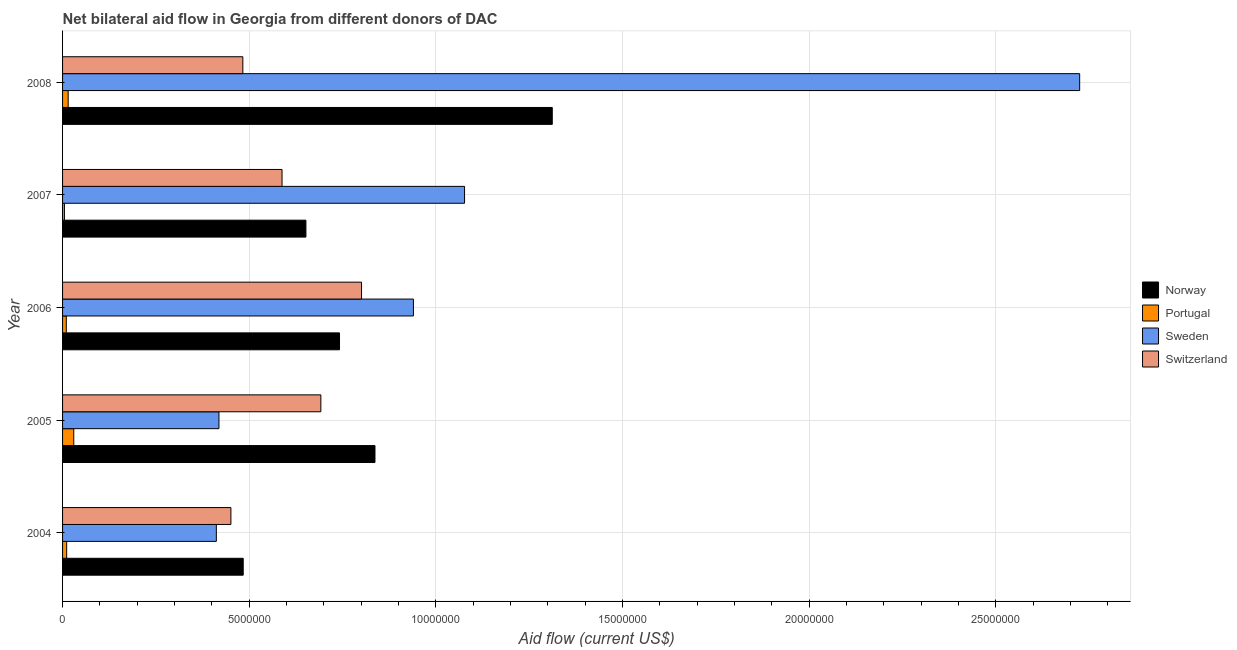Are the number of bars per tick equal to the number of legend labels?
Your answer should be compact. Yes. Are the number of bars on each tick of the Y-axis equal?
Provide a succinct answer. Yes. How many bars are there on the 3rd tick from the top?
Offer a terse response. 4. What is the amount of aid given by portugal in 2008?
Provide a short and direct response. 1.50e+05. Across all years, what is the maximum amount of aid given by sweden?
Make the answer very short. 2.72e+07. Across all years, what is the minimum amount of aid given by switzerland?
Provide a succinct answer. 4.51e+06. In which year was the amount of aid given by sweden maximum?
Keep it short and to the point. 2008. What is the total amount of aid given by switzerland in the graph?
Your answer should be compact. 3.02e+07. What is the difference between the amount of aid given by portugal in 2005 and that in 2006?
Offer a terse response. 2.00e+05. What is the difference between the amount of aid given by norway in 2004 and the amount of aid given by sweden in 2006?
Offer a terse response. -4.56e+06. What is the average amount of aid given by sweden per year?
Your answer should be compact. 1.11e+07. In the year 2005, what is the difference between the amount of aid given by switzerland and amount of aid given by norway?
Your answer should be compact. -1.45e+06. What is the ratio of the amount of aid given by portugal in 2004 to that in 2005?
Offer a terse response. 0.37. Is the amount of aid given by sweden in 2007 less than that in 2008?
Keep it short and to the point. Yes. Is the difference between the amount of aid given by norway in 2005 and 2008 greater than the difference between the amount of aid given by switzerland in 2005 and 2008?
Keep it short and to the point. No. What is the difference between the highest and the second highest amount of aid given by sweden?
Offer a very short reply. 1.65e+07. What is the difference between the highest and the lowest amount of aid given by sweden?
Offer a terse response. 2.31e+07. What does the 2nd bar from the top in 2004 represents?
Make the answer very short. Sweden. What does the 4th bar from the bottom in 2008 represents?
Make the answer very short. Switzerland. Are all the bars in the graph horizontal?
Keep it short and to the point. Yes. Are the values on the major ticks of X-axis written in scientific E-notation?
Your answer should be very brief. No. How many legend labels are there?
Your answer should be very brief. 4. How are the legend labels stacked?
Make the answer very short. Vertical. What is the title of the graph?
Provide a succinct answer. Net bilateral aid flow in Georgia from different donors of DAC. What is the label or title of the X-axis?
Provide a short and direct response. Aid flow (current US$). What is the Aid flow (current US$) in Norway in 2004?
Your answer should be very brief. 4.84e+06. What is the Aid flow (current US$) of Portugal in 2004?
Ensure brevity in your answer.  1.10e+05. What is the Aid flow (current US$) of Sweden in 2004?
Offer a terse response. 4.12e+06. What is the Aid flow (current US$) of Switzerland in 2004?
Your response must be concise. 4.51e+06. What is the Aid flow (current US$) of Norway in 2005?
Make the answer very short. 8.37e+06. What is the Aid flow (current US$) in Portugal in 2005?
Your answer should be very brief. 3.00e+05. What is the Aid flow (current US$) of Sweden in 2005?
Make the answer very short. 4.19e+06. What is the Aid flow (current US$) of Switzerland in 2005?
Provide a short and direct response. 6.92e+06. What is the Aid flow (current US$) in Norway in 2006?
Offer a terse response. 7.42e+06. What is the Aid flow (current US$) of Sweden in 2006?
Give a very brief answer. 9.40e+06. What is the Aid flow (current US$) of Switzerland in 2006?
Offer a terse response. 8.01e+06. What is the Aid flow (current US$) in Norway in 2007?
Keep it short and to the point. 6.52e+06. What is the Aid flow (current US$) of Sweden in 2007?
Your answer should be very brief. 1.08e+07. What is the Aid flow (current US$) of Switzerland in 2007?
Keep it short and to the point. 5.88e+06. What is the Aid flow (current US$) in Norway in 2008?
Your answer should be compact. 1.31e+07. What is the Aid flow (current US$) of Portugal in 2008?
Your answer should be compact. 1.50e+05. What is the Aid flow (current US$) in Sweden in 2008?
Keep it short and to the point. 2.72e+07. What is the Aid flow (current US$) in Switzerland in 2008?
Your response must be concise. 4.83e+06. Across all years, what is the maximum Aid flow (current US$) in Norway?
Make the answer very short. 1.31e+07. Across all years, what is the maximum Aid flow (current US$) in Portugal?
Offer a terse response. 3.00e+05. Across all years, what is the maximum Aid flow (current US$) of Sweden?
Make the answer very short. 2.72e+07. Across all years, what is the maximum Aid flow (current US$) in Switzerland?
Give a very brief answer. 8.01e+06. Across all years, what is the minimum Aid flow (current US$) in Norway?
Ensure brevity in your answer.  4.84e+06. Across all years, what is the minimum Aid flow (current US$) in Portugal?
Your response must be concise. 5.00e+04. Across all years, what is the minimum Aid flow (current US$) of Sweden?
Your answer should be very brief. 4.12e+06. Across all years, what is the minimum Aid flow (current US$) of Switzerland?
Provide a short and direct response. 4.51e+06. What is the total Aid flow (current US$) in Norway in the graph?
Give a very brief answer. 4.03e+07. What is the total Aid flow (current US$) in Portugal in the graph?
Your answer should be compact. 7.10e+05. What is the total Aid flow (current US$) in Sweden in the graph?
Offer a very short reply. 5.57e+07. What is the total Aid flow (current US$) of Switzerland in the graph?
Offer a very short reply. 3.02e+07. What is the difference between the Aid flow (current US$) of Norway in 2004 and that in 2005?
Give a very brief answer. -3.53e+06. What is the difference between the Aid flow (current US$) in Sweden in 2004 and that in 2005?
Make the answer very short. -7.00e+04. What is the difference between the Aid flow (current US$) in Switzerland in 2004 and that in 2005?
Offer a terse response. -2.41e+06. What is the difference between the Aid flow (current US$) of Norway in 2004 and that in 2006?
Provide a short and direct response. -2.58e+06. What is the difference between the Aid flow (current US$) of Portugal in 2004 and that in 2006?
Your response must be concise. 10000. What is the difference between the Aid flow (current US$) in Sweden in 2004 and that in 2006?
Give a very brief answer. -5.28e+06. What is the difference between the Aid flow (current US$) in Switzerland in 2004 and that in 2006?
Make the answer very short. -3.50e+06. What is the difference between the Aid flow (current US$) in Norway in 2004 and that in 2007?
Offer a terse response. -1.68e+06. What is the difference between the Aid flow (current US$) of Sweden in 2004 and that in 2007?
Your answer should be compact. -6.65e+06. What is the difference between the Aid flow (current US$) of Switzerland in 2004 and that in 2007?
Provide a succinct answer. -1.37e+06. What is the difference between the Aid flow (current US$) in Norway in 2004 and that in 2008?
Keep it short and to the point. -8.28e+06. What is the difference between the Aid flow (current US$) of Portugal in 2004 and that in 2008?
Keep it short and to the point. -4.00e+04. What is the difference between the Aid flow (current US$) of Sweden in 2004 and that in 2008?
Provide a succinct answer. -2.31e+07. What is the difference between the Aid flow (current US$) in Switzerland in 2004 and that in 2008?
Keep it short and to the point. -3.20e+05. What is the difference between the Aid flow (current US$) of Norway in 2005 and that in 2006?
Your answer should be compact. 9.50e+05. What is the difference between the Aid flow (current US$) in Sweden in 2005 and that in 2006?
Provide a succinct answer. -5.21e+06. What is the difference between the Aid flow (current US$) of Switzerland in 2005 and that in 2006?
Give a very brief answer. -1.09e+06. What is the difference between the Aid flow (current US$) of Norway in 2005 and that in 2007?
Offer a very short reply. 1.85e+06. What is the difference between the Aid flow (current US$) in Sweden in 2005 and that in 2007?
Your response must be concise. -6.58e+06. What is the difference between the Aid flow (current US$) of Switzerland in 2005 and that in 2007?
Ensure brevity in your answer.  1.04e+06. What is the difference between the Aid flow (current US$) of Norway in 2005 and that in 2008?
Offer a very short reply. -4.75e+06. What is the difference between the Aid flow (current US$) in Portugal in 2005 and that in 2008?
Make the answer very short. 1.50e+05. What is the difference between the Aid flow (current US$) in Sweden in 2005 and that in 2008?
Make the answer very short. -2.31e+07. What is the difference between the Aid flow (current US$) in Switzerland in 2005 and that in 2008?
Make the answer very short. 2.09e+06. What is the difference between the Aid flow (current US$) of Sweden in 2006 and that in 2007?
Ensure brevity in your answer.  -1.37e+06. What is the difference between the Aid flow (current US$) in Switzerland in 2006 and that in 2007?
Give a very brief answer. 2.13e+06. What is the difference between the Aid flow (current US$) of Norway in 2006 and that in 2008?
Make the answer very short. -5.70e+06. What is the difference between the Aid flow (current US$) of Portugal in 2006 and that in 2008?
Give a very brief answer. -5.00e+04. What is the difference between the Aid flow (current US$) in Sweden in 2006 and that in 2008?
Ensure brevity in your answer.  -1.78e+07. What is the difference between the Aid flow (current US$) in Switzerland in 2006 and that in 2008?
Keep it short and to the point. 3.18e+06. What is the difference between the Aid flow (current US$) in Norway in 2007 and that in 2008?
Give a very brief answer. -6.60e+06. What is the difference between the Aid flow (current US$) in Sweden in 2007 and that in 2008?
Keep it short and to the point. -1.65e+07. What is the difference between the Aid flow (current US$) of Switzerland in 2007 and that in 2008?
Keep it short and to the point. 1.05e+06. What is the difference between the Aid flow (current US$) of Norway in 2004 and the Aid flow (current US$) of Portugal in 2005?
Your answer should be very brief. 4.54e+06. What is the difference between the Aid flow (current US$) of Norway in 2004 and the Aid flow (current US$) of Sweden in 2005?
Give a very brief answer. 6.50e+05. What is the difference between the Aid flow (current US$) in Norway in 2004 and the Aid flow (current US$) in Switzerland in 2005?
Your answer should be very brief. -2.08e+06. What is the difference between the Aid flow (current US$) in Portugal in 2004 and the Aid flow (current US$) in Sweden in 2005?
Your answer should be very brief. -4.08e+06. What is the difference between the Aid flow (current US$) in Portugal in 2004 and the Aid flow (current US$) in Switzerland in 2005?
Ensure brevity in your answer.  -6.81e+06. What is the difference between the Aid flow (current US$) of Sweden in 2004 and the Aid flow (current US$) of Switzerland in 2005?
Ensure brevity in your answer.  -2.80e+06. What is the difference between the Aid flow (current US$) of Norway in 2004 and the Aid flow (current US$) of Portugal in 2006?
Ensure brevity in your answer.  4.74e+06. What is the difference between the Aid flow (current US$) in Norway in 2004 and the Aid flow (current US$) in Sweden in 2006?
Provide a succinct answer. -4.56e+06. What is the difference between the Aid flow (current US$) of Norway in 2004 and the Aid flow (current US$) of Switzerland in 2006?
Offer a terse response. -3.17e+06. What is the difference between the Aid flow (current US$) of Portugal in 2004 and the Aid flow (current US$) of Sweden in 2006?
Offer a terse response. -9.29e+06. What is the difference between the Aid flow (current US$) in Portugal in 2004 and the Aid flow (current US$) in Switzerland in 2006?
Ensure brevity in your answer.  -7.90e+06. What is the difference between the Aid flow (current US$) of Sweden in 2004 and the Aid flow (current US$) of Switzerland in 2006?
Your response must be concise. -3.89e+06. What is the difference between the Aid flow (current US$) in Norway in 2004 and the Aid flow (current US$) in Portugal in 2007?
Your answer should be compact. 4.79e+06. What is the difference between the Aid flow (current US$) of Norway in 2004 and the Aid flow (current US$) of Sweden in 2007?
Give a very brief answer. -5.93e+06. What is the difference between the Aid flow (current US$) in Norway in 2004 and the Aid flow (current US$) in Switzerland in 2007?
Your answer should be compact. -1.04e+06. What is the difference between the Aid flow (current US$) in Portugal in 2004 and the Aid flow (current US$) in Sweden in 2007?
Keep it short and to the point. -1.07e+07. What is the difference between the Aid flow (current US$) in Portugal in 2004 and the Aid flow (current US$) in Switzerland in 2007?
Give a very brief answer. -5.77e+06. What is the difference between the Aid flow (current US$) of Sweden in 2004 and the Aid flow (current US$) of Switzerland in 2007?
Provide a short and direct response. -1.76e+06. What is the difference between the Aid flow (current US$) of Norway in 2004 and the Aid flow (current US$) of Portugal in 2008?
Your answer should be very brief. 4.69e+06. What is the difference between the Aid flow (current US$) in Norway in 2004 and the Aid flow (current US$) in Sweden in 2008?
Keep it short and to the point. -2.24e+07. What is the difference between the Aid flow (current US$) in Norway in 2004 and the Aid flow (current US$) in Switzerland in 2008?
Your response must be concise. 10000. What is the difference between the Aid flow (current US$) in Portugal in 2004 and the Aid flow (current US$) in Sweden in 2008?
Your answer should be very brief. -2.71e+07. What is the difference between the Aid flow (current US$) in Portugal in 2004 and the Aid flow (current US$) in Switzerland in 2008?
Your response must be concise. -4.72e+06. What is the difference between the Aid flow (current US$) in Sweden in 2004 and the Aid flow (current US$) in Switzerland in 2008?
Provide a short and direct response. -7.10e+05. What is the difference between the Aid flow (current US$) in Norway in 2005 and the Aid flow (current US$) in Portugal in 2006?
Make the answer very short. 8.27e+06. What is the difference between the Aid flow (current US$) of Norway in 2005 and the Aid flow (current US$) of Sweden in 2006?
Keep it short and to the point. -1.03e+06. What is the difference between the Aid flow (current US$) in Norway in 2005 and the Aid flow (current US$) in Switzerland in 2006?
Give a very brief answer. 3.60e+05. What is the difference between the Aid flow (current US$) in Portugal in 2005 and the Aid flow (current US$) in Sweden in 2006?
Your response must be concise. -9.10e+06. What is the difference between the Aid flow (current US$) of Portugal in 2005 and the Aid flow (current US$) of Switzerland in 2006?
Offer a terse response. -7.71e+06. What is the difference between the Aid flow (current US$) in Sweden in 2005 and the Aid flow (current US$) in Switzerland in 2006?
Make the answer very short. -3.82e+06. What is the difference between the Aid flow (current US$) of Norway in 2005 and the Aid flow (current US$) of Portugal in 2007?
Offer a very short reply. 8.32e+06. What is the difference between the Aid flow (current US$) of Norway in 2005 and the Aid flow (current US$) of Sweden in 2007?
Your answer should be very brief. -2.40e+06. What is the difference between the Aid flow (current US$) of Norway in 2005 and the Aid flow (current US$) of Switzerland in 2007?
Give a very brief answer. 2.49e+06. What is the difference between the Aid flow (current US$) in Portugal in 2005 and the Aid flow (current US$) in Sweden in 2007?
Ensure brevity in your answer.  -1.05e+07. What is the difference between the Aid flow (current US$) in Portugal in 2005 and the Aid flow (current US$) in Switzerland in 2007?
Your answer should be compact. -5.58e+06. What is the difference between the Aid flow (current US$) in Sweden in 2005 and the Aid flow (current US$) in Switzerland in 2007?
Your answer should be very brief. -1.69e+06. What is the difference between the Aid flow (current US$) in Norway in 2005 and the Aid flow (current US$) in Portugal in 2008?
Your response must be concise. 8.22e+06. What is the difference between the Aid flow (current US$) of Norway in 2005 and the Aid flow (current US$) of Sweden in 2008?
Your answer should be compact. -1.89e+07. What is the difference between the Aid flow (current US$) of Norway in 2005 and the Aid flow (current US$) of Switzerland in 2008?
Offer a very short reply. 3.54e+06. What is the difference between the Aid flow (current US$) in Portugal in 2005 and the Aid flow (current US$) in Sweden in 2008?
Your response must be concise. -2.70e+07. What is the difference between the Aid flow (current US$) of Portugal in 2005 and the Aid flow (current US$) of Switzerland in 2008?
Your answer should be compact. -4.53e+06. What is the difference between the Aid flow (current US$) of Sweden in 2005 and the Aid flow (current US$) of Switzerland in 2008?
Give a very brief answer. -6.40e+05. What is the difference between the Aid flow (current US$) of Norway in 2006 and the Aid flow (current US$) of Portugal in 2007?
Keep it short and to the point. 7.37e+06. What is the difference between the Aid flow (current US$) of Norway in 2006 and the Aid flow (current US$) of Sweden in 2007?
Offer a terse response. -3.35e+06. What is the difference between the Aid flow (current US$) of Norway in 2006 and the Aid flow (current US$) of Switzerland in 2007?
Ensure brevity in your answer.  1.54e+06. What is the difference between the Aid flow (current US$) of Portugal in 2006 and the Aid flow (current US$) of Sweden in 2007?
Your answer should be very brief. -1.07e+07. What is the difference between the Aid flow (current US$) in Portugal in 2006 and the Aid flow (current US$) in Switzerland in 2007?
Give a very brief answer. -5.78e+06. What is the difference between the Aid flow (current US$) in Sweden in 2006 and the Aid flow (current US$) in Switzerland in 2007?
Make the answer very short. 3.52e+06. What is the difference between the Aid flow (current US$) in Norway in 2006 and the Aid flow (current US$) in Portugal in 2008?
Give a very brief answer. 7.27e+06. What is the difference between the Aid flow (current US$) in Norway in 2006 and the Aid flow (current US$) in Sweden in 2008?
Make the answer very short. -1.98e+07. What is the difference between the Aid flow (current US$) of Norway in 2006 and the Aid flow (current US$) of Switzerland in 2008?
Provide a succinct answer. 2.59e+06. What is the difference between the Aid flow (current US$) in Portugal in 2006 and the Aid flow (current US$) in Sweden in 2008?
Offer a very short reply. -2.72e+07. What is the difference between the Aid flow (current US$) in Portugal in 2006 and the Aid flow (current US$) in Switzerland in 2008?
Make the answer very short. -4.73e+06. What is the difference between the Aid flow (current US$) in Sweden in 2006 and the Aid flow (current US$) in Switzerland in 2008?
Your response must be concise. 4.57e+06. What is the difference between the Aid flow (current US$) in Norway in 2007 and the Aid flow (current US$) in Portugal in 2008?
Make the answer very short. 6.37e+06. What is the difference between the Aid flow (current US$) of Norway in 2007 and the Aid flow (current US$) of Sweden in 2008?
Provide a short and direct response. -2.07e+07. What is the difference between the Aid flow (current US$) in Norway in 2007 and the Aid flow (current US$) in Switzerland in 2008?
Offer a terse response. 1.69e+06. What is the difference between the Aid flow (current US$) in Portugal in 2007 and the Aid flow (current US$) in Sweden in 2008?
Provide a short and direct response. -2.72e+07. What is the difference between the Aid flow (current US$) in Portugal in 2007 and the Aid flow (current US$) in Switzerland in 2008?
Keep it short and to the point. -4.78e+06. What is the difference between the Aid flow (current US$) of Sweden in 2007 and the Aid flow (current US$) of Switzerland in 2008?
Offer a very short reply. 5.94e+06. What is the average Aid flow (current US$) in Norway per year?
Your response must be concise. 8.05e+06. What is the average Aid flow (current US$) in Portugal per year?
Keep it short and to the point. 1.42e+05. What is the average Aid flow (current US$) in Sweden per year?
Provide a short and direct response. 1.11e+07. What is the average Aid flow (current US$) of Switzerland per year?
Offer a terse response. 6.03e+06. In the year 2004, what is the difference between the Aid flow (current US$) of Norway and Aid flow (current US$) of Portugal?
Your answer should be compact. 4.73e+06. In the year 2004, what is the difference between the Aid flow (current US$) in Norway and Aid flow (current US$) in Sweden?
Make the answer very short. 7.20e+05. In the year 2004, what is the difference between the Aid flow (current US$) in Portugal and Aid flow (current US$) in Sweden?
Your answer should be very brief. -4.01e+06. In the year 2004, what is the difference between the Aid flow (current US$) of Portugal and Aid flow (current US$) of Switzerland?
Keep it short and to the point. -4.40e+06. In the year 2004, what is the difference between the Aid flow (current US$) of Sweden and Aid flow (current US$) of Switzerland?
Make the answer very short. -3.90e+05. In the year 2005, what is the difference between the Aid flow (current US$) of Norway and Aid flow (current US$) of Portugal?
Give a very brief answer. 8.07e+06. In the year 2005, what is the difference between the Aid flow (current US$) of Norway and Aid flow (current US$) of Sweden?
Ensure brevity in your answer.  4.18e+06. In the year 2005, what is the difference between the Aid flow (current US$) of Norway and Aid flow (current US$) of Switzerland?
Provide a succinct answer. 1.45e+06. In the year 2005, what is the difference between the Aid flow (current US$) of Portugal and Aid flow (current US$) of Sweden?
Offer a terse response. -3.89e+06. In the year 2005, what is the difference between the Aid flow (current US$) of Portugal and Aid flow (current US$) of Switzerland?
Make the answer very short. -6.62e+06. In the year 2005, what is the difference between the Aid flow (current US$) of Sweden and Aid flow (current US$) of Switzerland?
Offer a very short reply. -2.73e+06. In the year 2006, what is the difference between the Aid flow (current US$) of Norway and Aid flow (current US$) of Portugal?
Make the answer very short. 7.32e+06. In the year 2006, what is the difference between the Aid flow (current US$) of Norway and Aid flow (current US$) of Sweden?
Make the answer very short. -1.98e+06. In the year 2006, what is the difference between the Aid flow (current US$) of Norway and Aid flow (current US$) of Switzerland?
Your answer should be compact. -5.90e+05. In the year 2006, what is the difference between the Aid flow (current US$) in Portugal and Aid flow (current US$) in Sweden?
Give a very brief answer. -9.30e+06. In the year 2006, what is the difference between the Aid flow (current US$) in Portugal and Aid flow (current US$) in Switzerland?
Provide a short and direct response. -7.91e+06. In the year 2006, what is the difference between the Aid flow (current US$) of Sweden and Aid flow (current US$) of Switzerland?
Your response must be concise. 1.39e+06. In the year 2007, what is the difference between the Aid flow (current US$) of Norway and Aid flow (current US$) of Portugal?
Ensure brevity in your answer.  6.47e+06. In the year 2007, what is the difference between the Aid flow (current US$) in Norway and Aid flow (current US$) in Sweden?
Provide a succinct answer. -4.25e+06. In the year 2007, what is the difference between the Aid flow (current US$) in Norway and Aid flow (current US$) in Switzerland?
Ensure brevity in your answer.  6.40e+05. In the year 2007, what is the difference between the Aid flow (current US$) in Portugal and Aid flow (current US$) in Sweden?
Provide a succinct answer. -1.07e+07. In the year 2007, what is the difference between the Aid flow (current US$) of Portugal and Aid flow (current US$) of Switzerland?
Ensure brevity in your answer.  -5.83e+06. In the year 2007, what is the difference between the Aid flow (current US$) in Sweden and Aid flow (current US$) in Switzerland?
Ensure brevity in your answer.  4.89e+06. In the year 2008, what is the difference between the Aid flow (current US$) in Norway and Aid flow (current US$) in Portugal?
Your answer should be compact. 1.30e+07. In the year 2008, what is the difference between the Aid flow (current US$) in Norway and Aid flow (current US$) in Sweden?
Make the answer very short. -1.41e+07. In the year 2008, what is the difference between the Aid flow (current US$) of Norway and Aid flow (current US$) of Switzerland?
Ensure brevity in your answer.  8.29e+06. In the year 2008, what is the difference between the Aid flow (current US$) of Portugal and Aid flow (current US$) of Sweden?
Your answer should be compact. -2.71e+07. In the year 2008, what is the difference between the Aid flow (current US$) of Portugal and Aid flow (current US$) of Switzerland?
Your response must be concise. -4.68e+06. In the year 2008, what is the difference between the Aid flow (current US$) in Sweden and Aid flow (current US$) in Switzerland?
Give a very brief answer. 2.24e+07. What is the ratio of the Aid flow (current US$) in Norway in 2004 to that in 2005?
Make the answer very short. 0.58. What is the ratio of the Aid flow (current US$) of Portugal in 2004 to that in 2005?
Provide a short and direct response. 0.37. What is the ratio of the Aid flow (current US$) in Sweden in 2004 to that in 2005?
Offer a very short reply. 0.98. What is the ratio of the Aid flow (current US$) in Switzerland in 2004 to that in 2005?
Your response must be concise. 0.65. What is the ratio of the Aid flow (current US$) of Norway in 2004 to that in 2006?
Your answer should be very brief. 0.65. What is the ratio of the Aid flow (current US$) in Sweden in 2004 to that in 2006?
Offer a terse response. 0.44. What is the ratio of the Aid flow (current US$) in Switzerland in 2004 to that in 2006?
Keep it short and to the point. 0.56. What is the ratio of the Aid flow (current US$) of Norway in 2004 to that in 2007?
Keep it short and to the point. 0.74. What is the ratio of the Aid flow (current US$) of Sweden in 2004 to that in 2007?
Ensure brevity in your answer.  0.38. What is the ratio of the Aid flow (current US$) in Switzerland in 2004 to that in 2007?
Your answer should be compact. 0.77. What is the ratio of the Aid flow (current US$) of Norway in 2004 to that in 2008?
Your answer should be compact. 0.37. What is the ratio of the Aid flow (current US$) in Portugal in 2004 to that in 2008?
Provide a succinct answer. 0.73. What is the ratio of the Aid flow (current US$) of Sweden in 2004 to that in 2008?
Make the answer very short. 0.15. What is the ratio of the Aid flow (current US$) of Switzerland in 2004 to that in 2008?
Provide a succinct answer. 0.93. What is the ratio of the Aid flow (current US$) in Norway in 2005 to that in 2006?
Your response must be concise. 1.13. What is the ratio of the Aid flow (current US$) of Portugal in 2005 to that in 2006?
Your response must be concise. 3. What is the ratio of the Aid flow (current US$) of Sweden in 2005 to that in 2006?
Your answer should be compact. 0.45. What is the ratio of the Aid flow (current US$) of Switzerland in 2005 to that in 2006?
Give a very brief answer. 0.86. What is the ratio of the Aid flow (current US$) in Norway in 2005 to that in 2007?
Your answer should be compact. 1.28. What is the ratio of the Aid flow (current US$) of Sweden in 2005 to that in 2007?
Make the answer very short. 0.39. What is the ratio of the Aid flow (current US$) of Switzerland in 2005 to that in 2007?
Offer a terse response. 1.18. What is the ratio of the Aid flow (current US$) of Norway in 2005 to that in 2008?
Your answer should be compact. 0.64. What is the ratio of the Aid flow (current US$) of Sweden in 2005 to that in 2008?
Your answer should be compact. 0.15. What is the ratio of the Aid flow (current US$) of Switzerland in 2005 to that in 2008?
Your answer should be compact. 1.43. What is the ratio of the Aid flow (current US$) in Norway in 2006 to that in 2007?
Offer a very short reply. 1.14. What is the ratio of the Aid flow (current US$) of Sweden in 2006 to that in 2007?
Your answer should be very brief. 0.87. What is the ratio of the Aid flow (current US$) of Switzerland in 2006 to that in 2007?
Make the answer very short. 1.36. What is the ratio of the Aid flow (current US$) of Norway in 2006 to that in 2008?
Ensure brevity in your answer.  0.57. What is the ratio of the Aid flow (current US$) of Sweden in 2006 to that in 2008?
Provide a short and direct response. 0.34. What is the ratio of the Aid flow (current US$) of Switzerland in 2006 to that in 2008?
Provide a succinct answer. 1.66. What is the ratio of the Aid flow (current US$) in Norway in 2007 to that in 2008?
Provide a succinct answer. 0.5. What is the ratio of the Aid flow (current US$) of Sweden in 2007 to that in 2008?
Provide a succinct answer. 0.4. What is the ratio of the Aid flow (current US$) in Switzerland in 2007 to that in 2008?
Ensure brevity in your answer.  1.22. What is the difference between the highest and the second highest Aid flow (current US$) of Norway?
Your response must be concise. 4.75e+06. What is the difference between the highest and the second highest Aid flow (current US$) in Portugal?
Your answer should be very brief. 1.50e+05. What is the difference between the highest and the second highest Aid flow (current US$) in Sweden?
Ensure brevity in your answer.  1.65e+07. What is the difference between the highest and the second highest Aid flow (current US$) in Switzerland?
Offer a very short reply. 1.09e+06. What is the difference between the highest and the lowest Aid flow (current US$) in Norway?
Provide a short and direct response. 8.28e+06. What is the difference between the highest and the lowest Aid flow (current US$) of Sweden?
Your answer should be compact. 2.31e+07. What is the difference between the highest and the lowest Aid flow (current US$) of Switzerland?
Make the answer very short. 3.50e+06. 